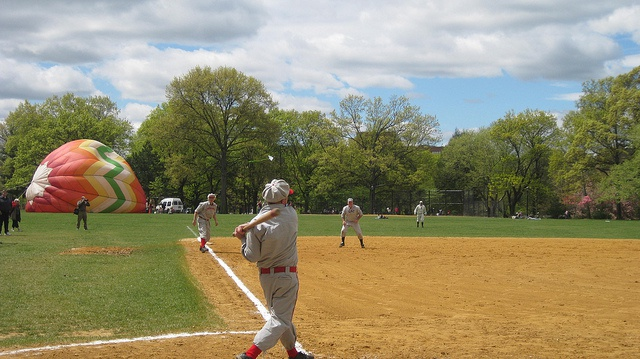Describe the objects in this image and their specific colors. I can see people in darkgray, gray, maroon, and lightgray tones, people in darkgray, gray, and maroon tones, people in darkgray, gray, and brown tones, people in darkgray, black, gray, darkgreen, and maroon tones, and people in darkgray, black, darkgreen, olive, and maroon tones in this image. 